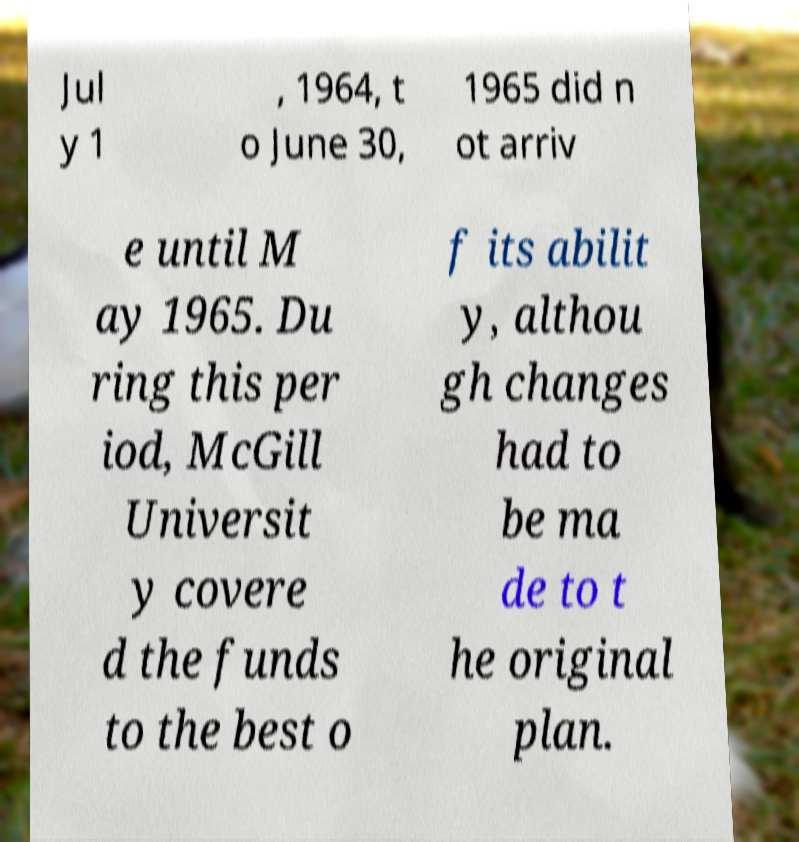What messages or text are displayed in this image? I need them in a readable, typed format. Jul y 1 , 1964, t o June 30, 1965 did n ot arriv e until M ay 1965. Du ring this per iod, McGill Universit y covere d the funds to the best o f its abilit y, althou gh changes had to be ma de to t he original plan. 